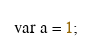<code> <loc_0><loc_0><loc_500><loc_500><_Swift_>var a = 1;</code> 